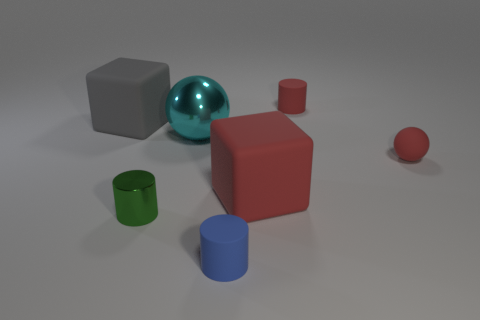The large block that is left of the big matte thing in front of the big gray object behind the large sphere is made of what material?
Make the answer very short. Rubber. Is there a gray object made of the same material as the tiny blue cylinder?
Your answer should be very brief. Yes. Is the green thing made of the same material as the tiny red cylinder?
Give a very brief answer. No. What number of cylinders are either blue objects or matte objects?
Offer a very short reply. 2. There is another cylinder that is made of the same material as the tiny blue cylinder; what is its color?
Make the answer very short. Red. Is the number of small blue matte cylinders less than the number of big yellow matte cylinders?
Provide a succinct answer. No. There is a small red matte object to the right of the small red matte cylinder; is it the same shape as the big rubber thing that is to the left of the blue object?
Provide a succinct answer. No. How many objects are either tiny green metallic cylinders or small matte things?
Give a very brief answer. 4. There is a ball that is the same size as the green metal object; what color is it?
Provide a short and direct response. Red. There is a cylinder on the left side of the large metallic ball; how many cyan spheres are behind it?
Give a very brief answer. 1. 